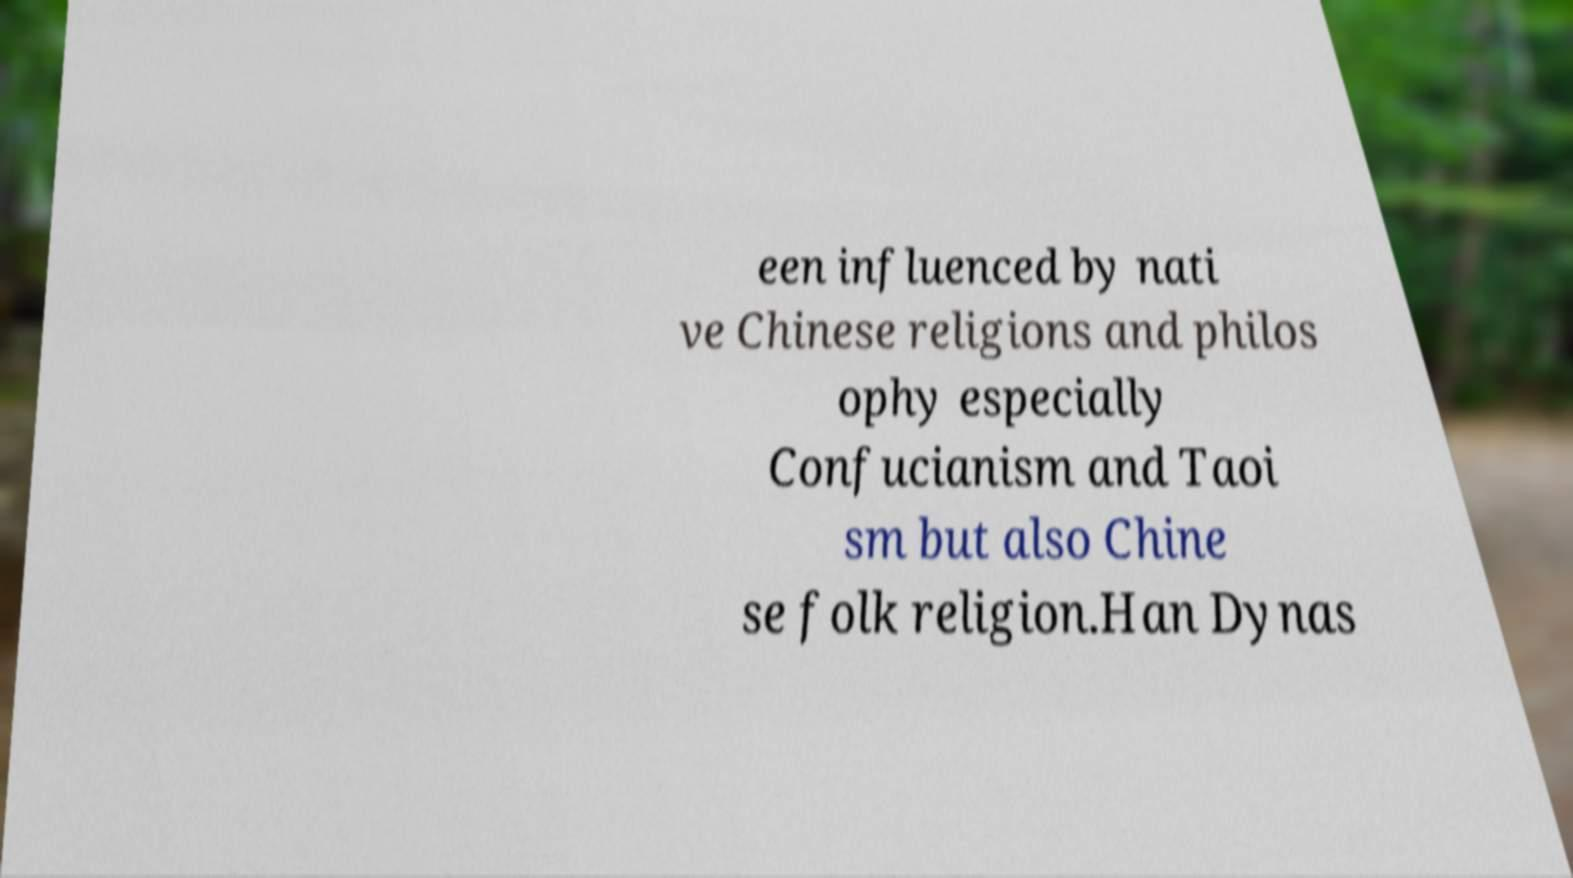For documentation purposes, I need the text within this image transcribed. Could you provide that? een influenced by nati ve Chinese religions and philos ophy especially Confucianism and Taoi sm but also Chine se folk religion.Han Dynas 